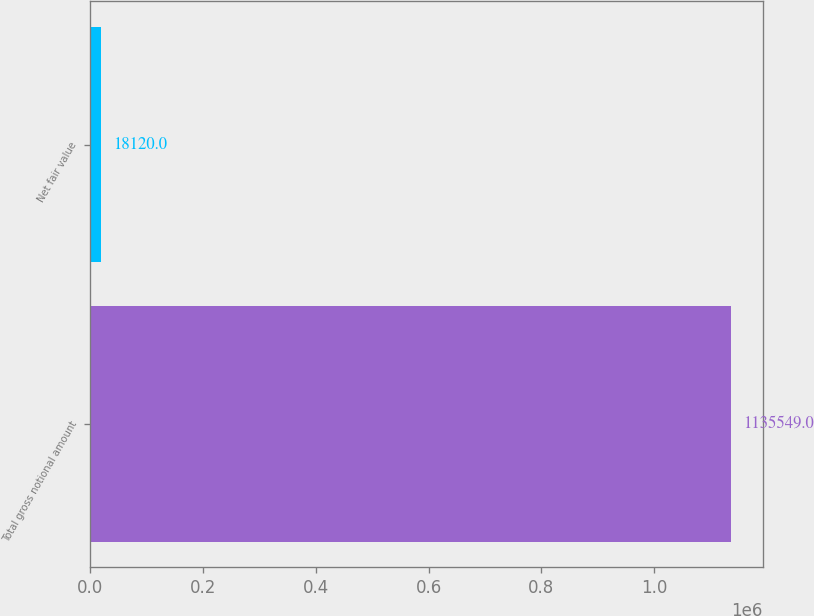Convert chart to OTSL. <chart><loc_0><loc_0><loc_500><loc_500><bar_chart><fcel>Total gross notional amount<fcel>Net fair value<nl><fcel>1.13555e+06<fcel>18120<nl></chart> 